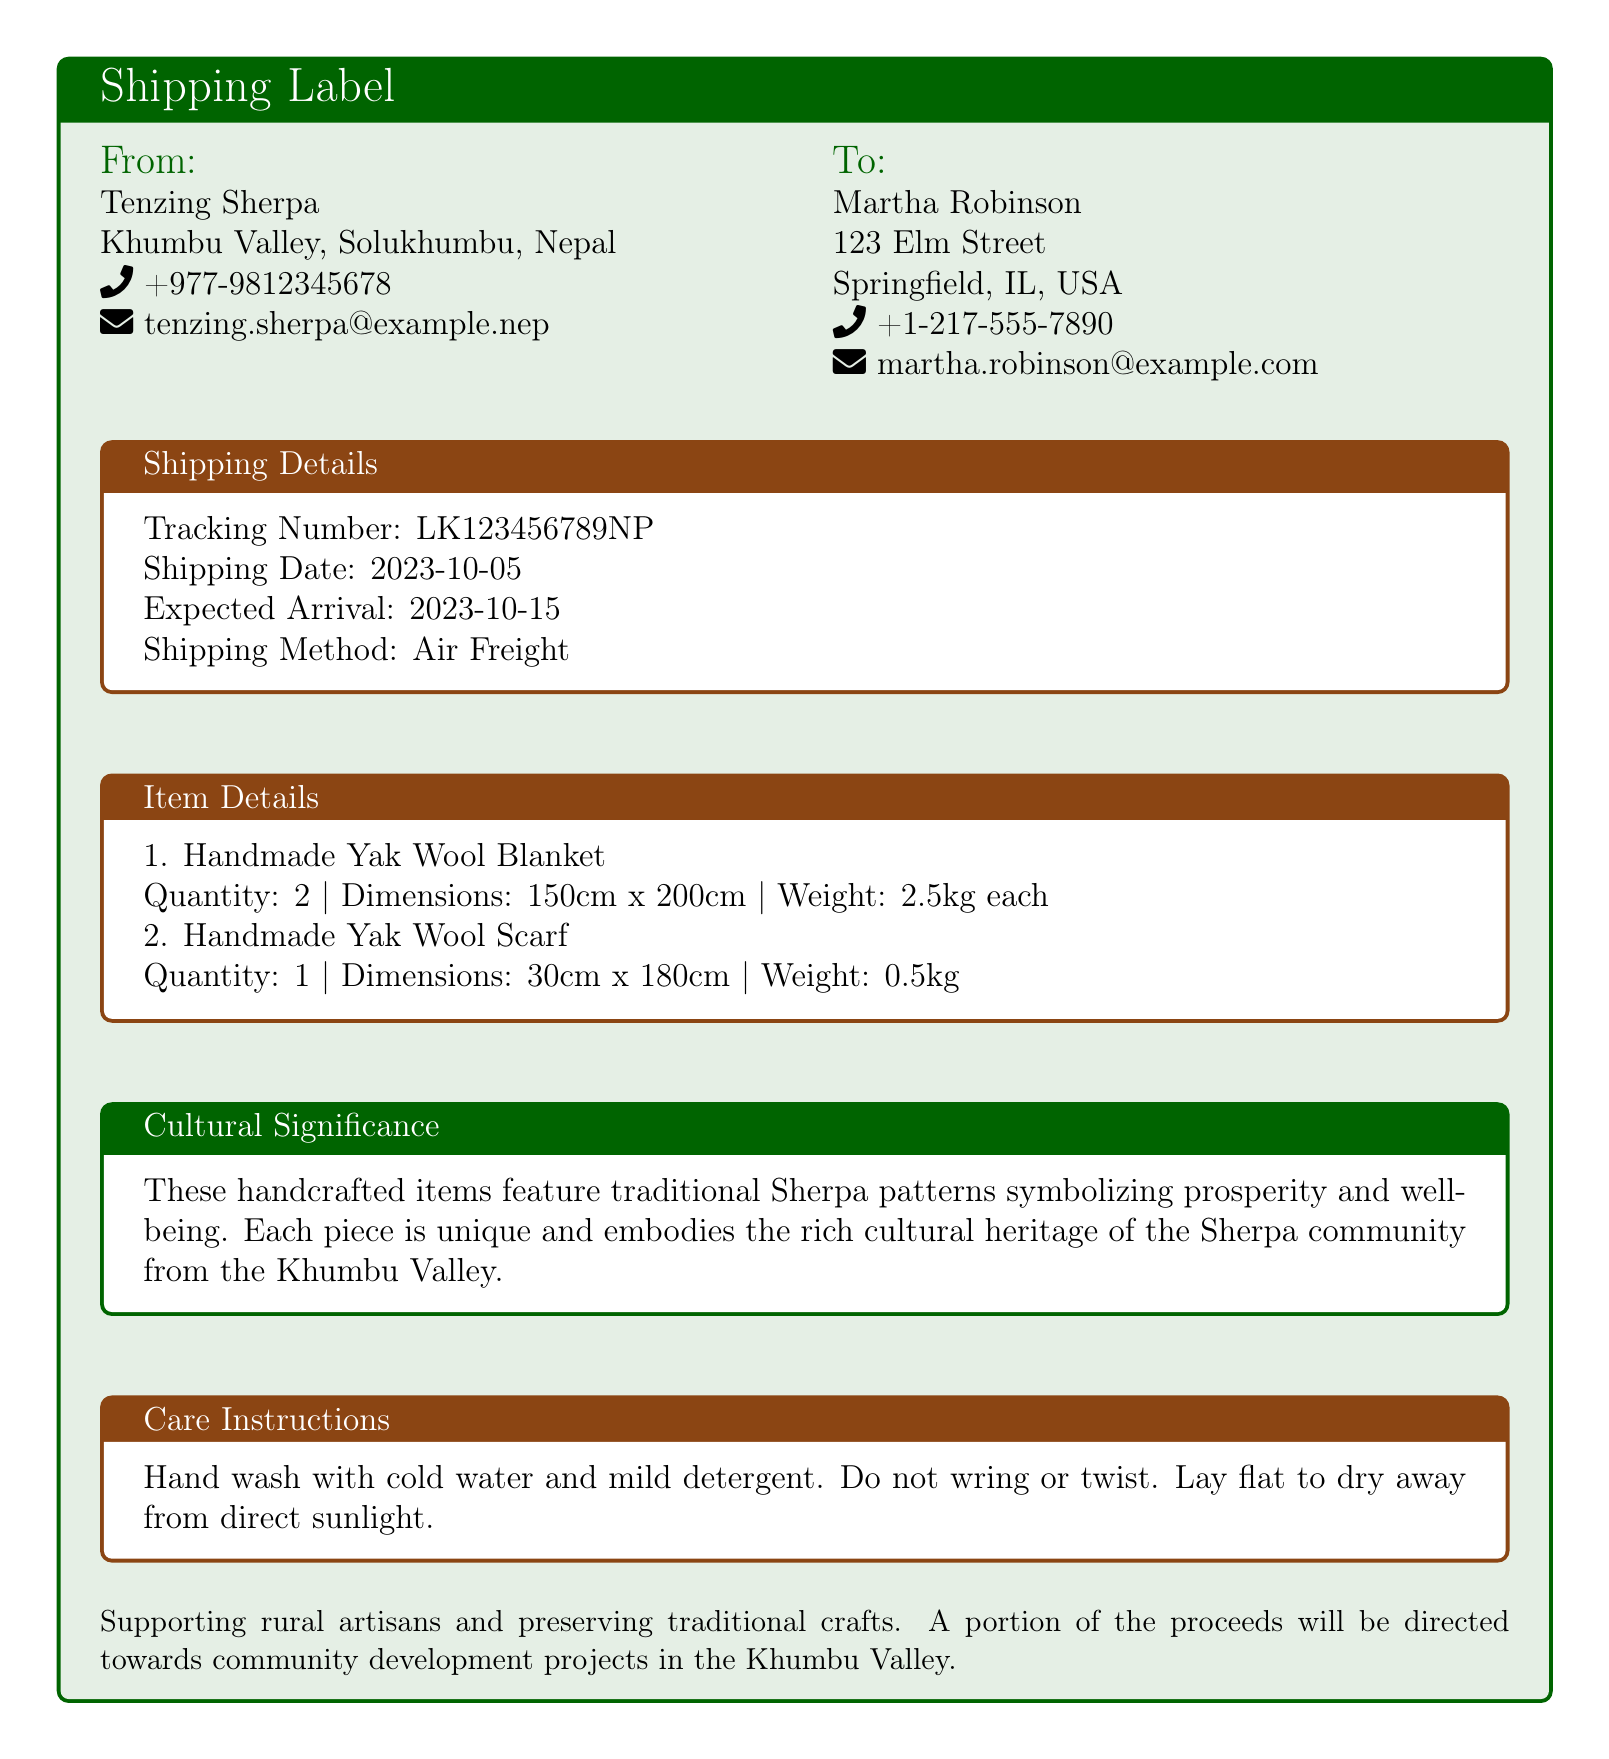What is the sender's name? The sender's name is listed at the top of the label under "From", which is Tenzing Sherpa.
Answer: Tenzing Sherpa What is the tracking number? The tracking number is specifically indicated under "Shipping Details" in the document.
Answer: LK123456789NP What is the expected arrival date? The expected arrival date is mentioned in the "Shipping Details" section of the label.
Answer: 2023-10-15 How many Yak Wool Blankets are being shipped? The quantity of Yak Wool Blankets is stated in the "Item Details" section.
Answer: 2 What are the care instructions for the items? The care instructions can be found in the "Care Instructions" section of the label.
Answer: Hand wash with cold water and mild detergent What does the cultural significance mention? The cultural significance section describes the meaning behind the handcrafted items.
Answer: Traditional Sherpa patterns symbolizing prosperity and well-being What is the weight of the Yak Wool Scarf? The weight of the Yak Wool Scarf is provided in the "Item Details" section.
Answer: 0.5kg What type of shipping method is used? The shipping method is clearly stated in the "Shipping Details" section.
Answer: Air Freight What is the sender's location? The sender's location is detailed under "From" as Khumbu Valley, Solukhumbu, Nepal.
Answer: Khumbu Valley, Solukhumbu, Nepal 